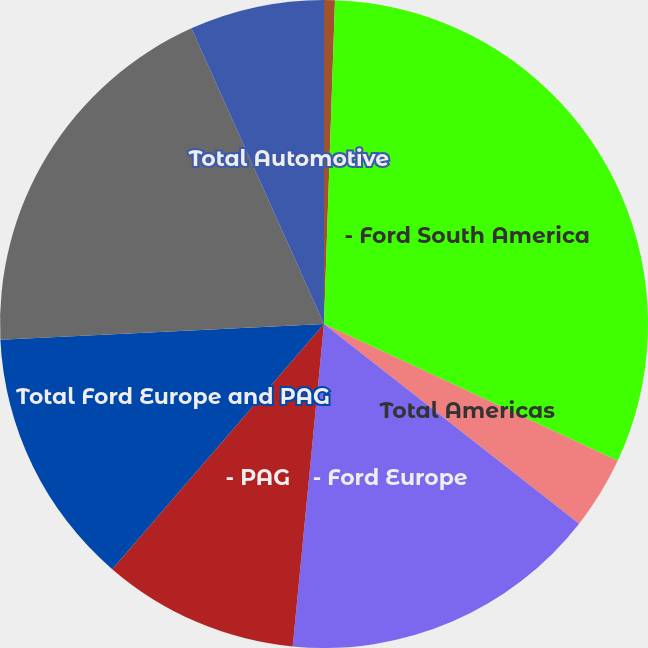Convert chart to OTSL. <chart><loc_0><loc_0><loc_500><loc_500><pie_chart><fcel>- Ford NorthAmerica<fcel>- Ford South America<fcel>Total Americas<fcel>- Ford Europe<fcel>- PAG<fcel>Total Ford Europe and PAG<fcel>Ford Asia Pacific and Africa<fcel>Total Automotive<nl><fcel>0.54%<fcel>31.4%<fcel>3.63%<fcel>15.97%<fcel>9.8%<fcel>12.89%<fcel>19.06%<fcel>6.71%<nl></chart> 